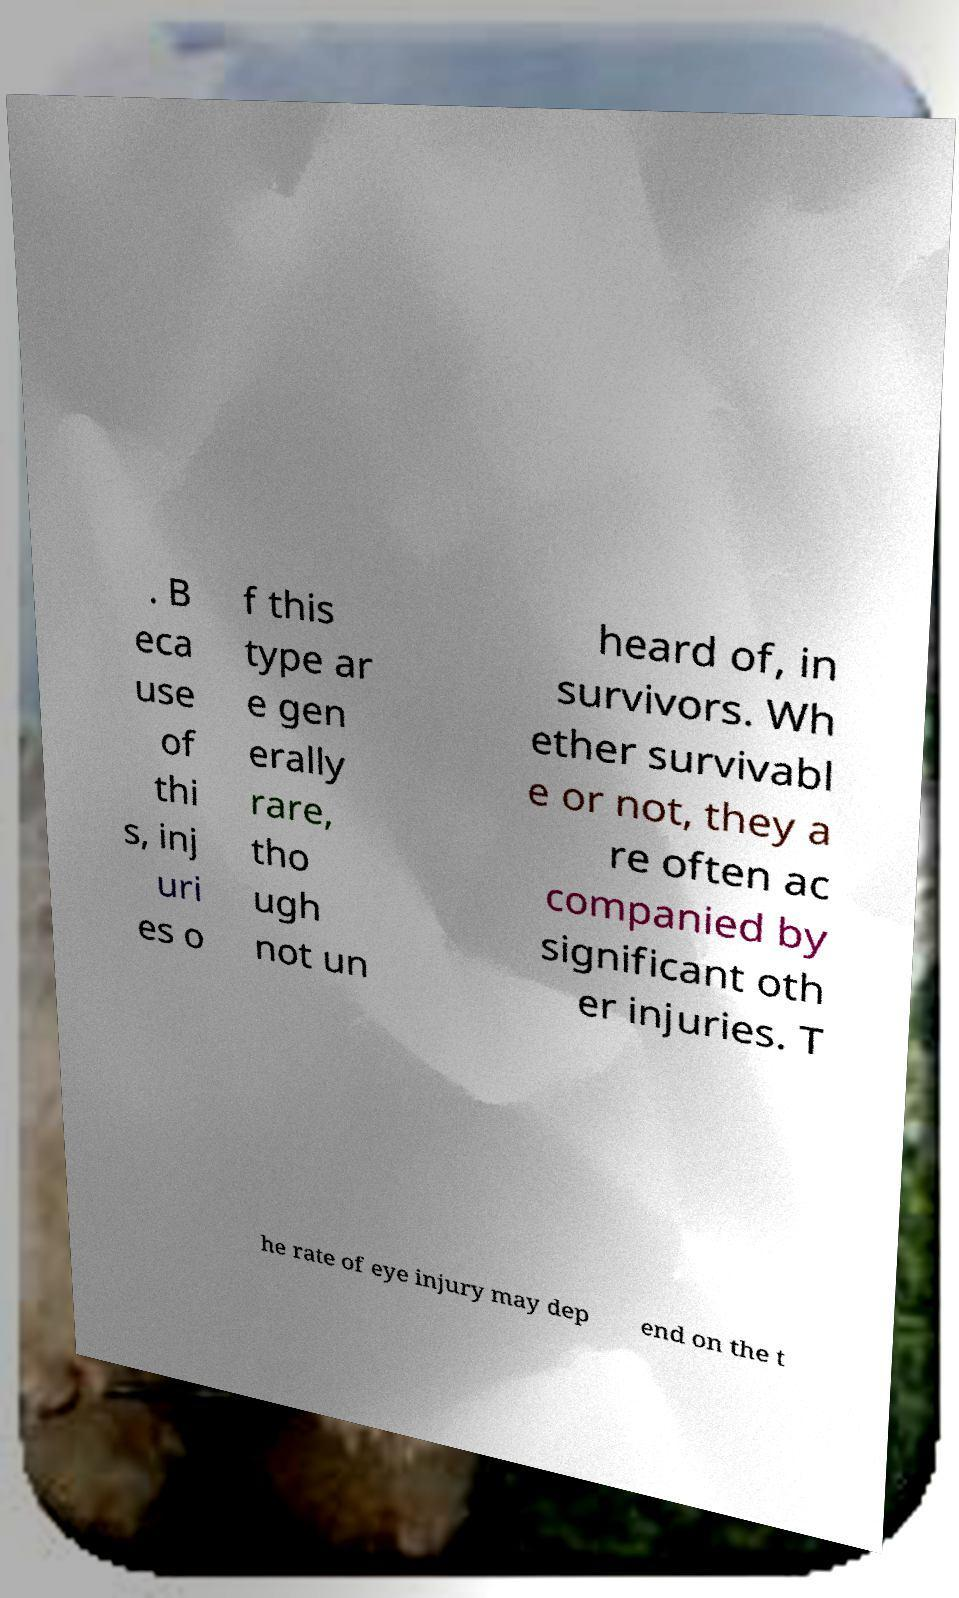Can you accurately transcribe the text from the provided image for me? . B eca use of thi s, inj uri es o f this type ar e gen erally rare, tho ugh not un heard of, in survivors. Wh ether survivabl e or not, they a re often ac companied by significant oth er injuries. T he rate of eye injury may dep end on the t 